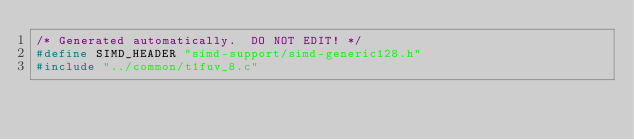Convert code to text. <code><loc_0><loc_0><loc_500><loc_500><_C_>/* Generated automatically.  DO NOT EDIT! */
#define SIMD_HEADER "simd-support/simd-generic128.h"
#include "../common/t1fuv_8.c"
</code> 